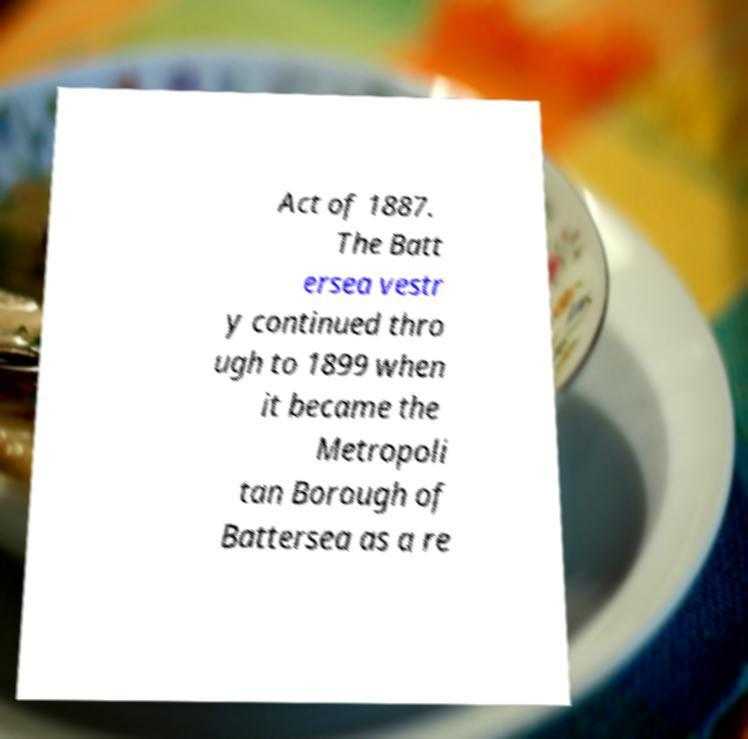Can you read and provide the text displayed in the image?This photo seems to have some interesting text. Can you extract and type it out for me? Act of 1887. The Batt ersea vestr y continued thro ugh to 1899 when it became the Metropoli tan Borough of Battersea as a re 